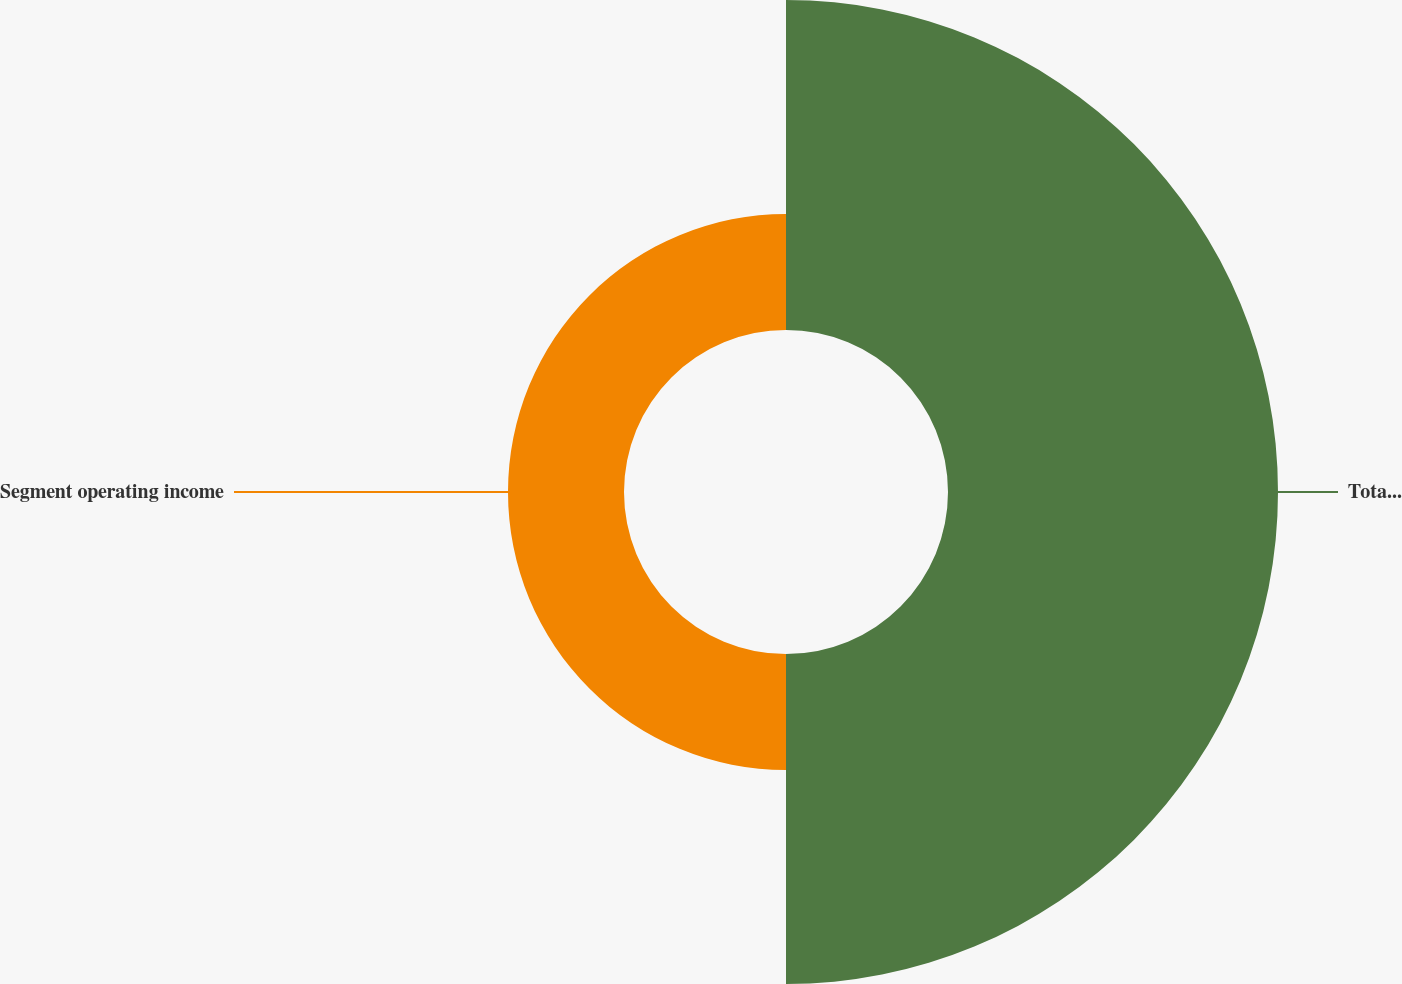Convert chart to OTSL. <chart><loc_0><loc_0><loc_500><loc_500><pie_chart><fcel>Total segment revenue<fcel>Segment operating income<nl><fcel>73.99%<fcel>26.01%<nl></chart> 